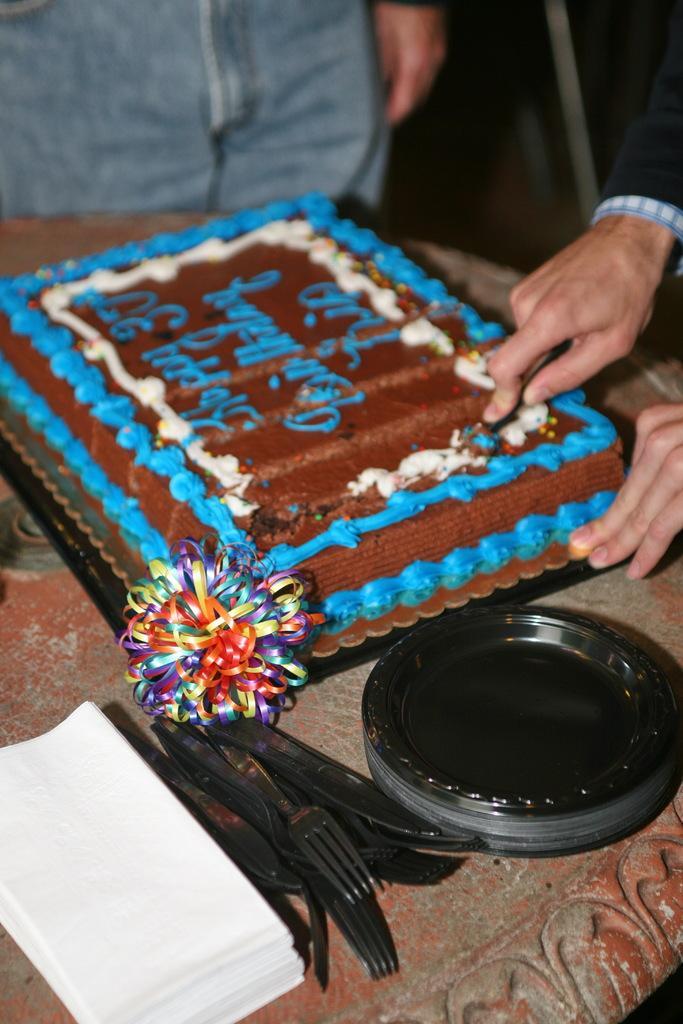Could you give a brief overview of what you see in this image? At the bottom of the image there is a brown table with tissues, forks and black plates. And also there is a cake with brown and blue cream. At the right corner of the image there is a person hand cutting the cake. And at the left top of the image there is a person. 